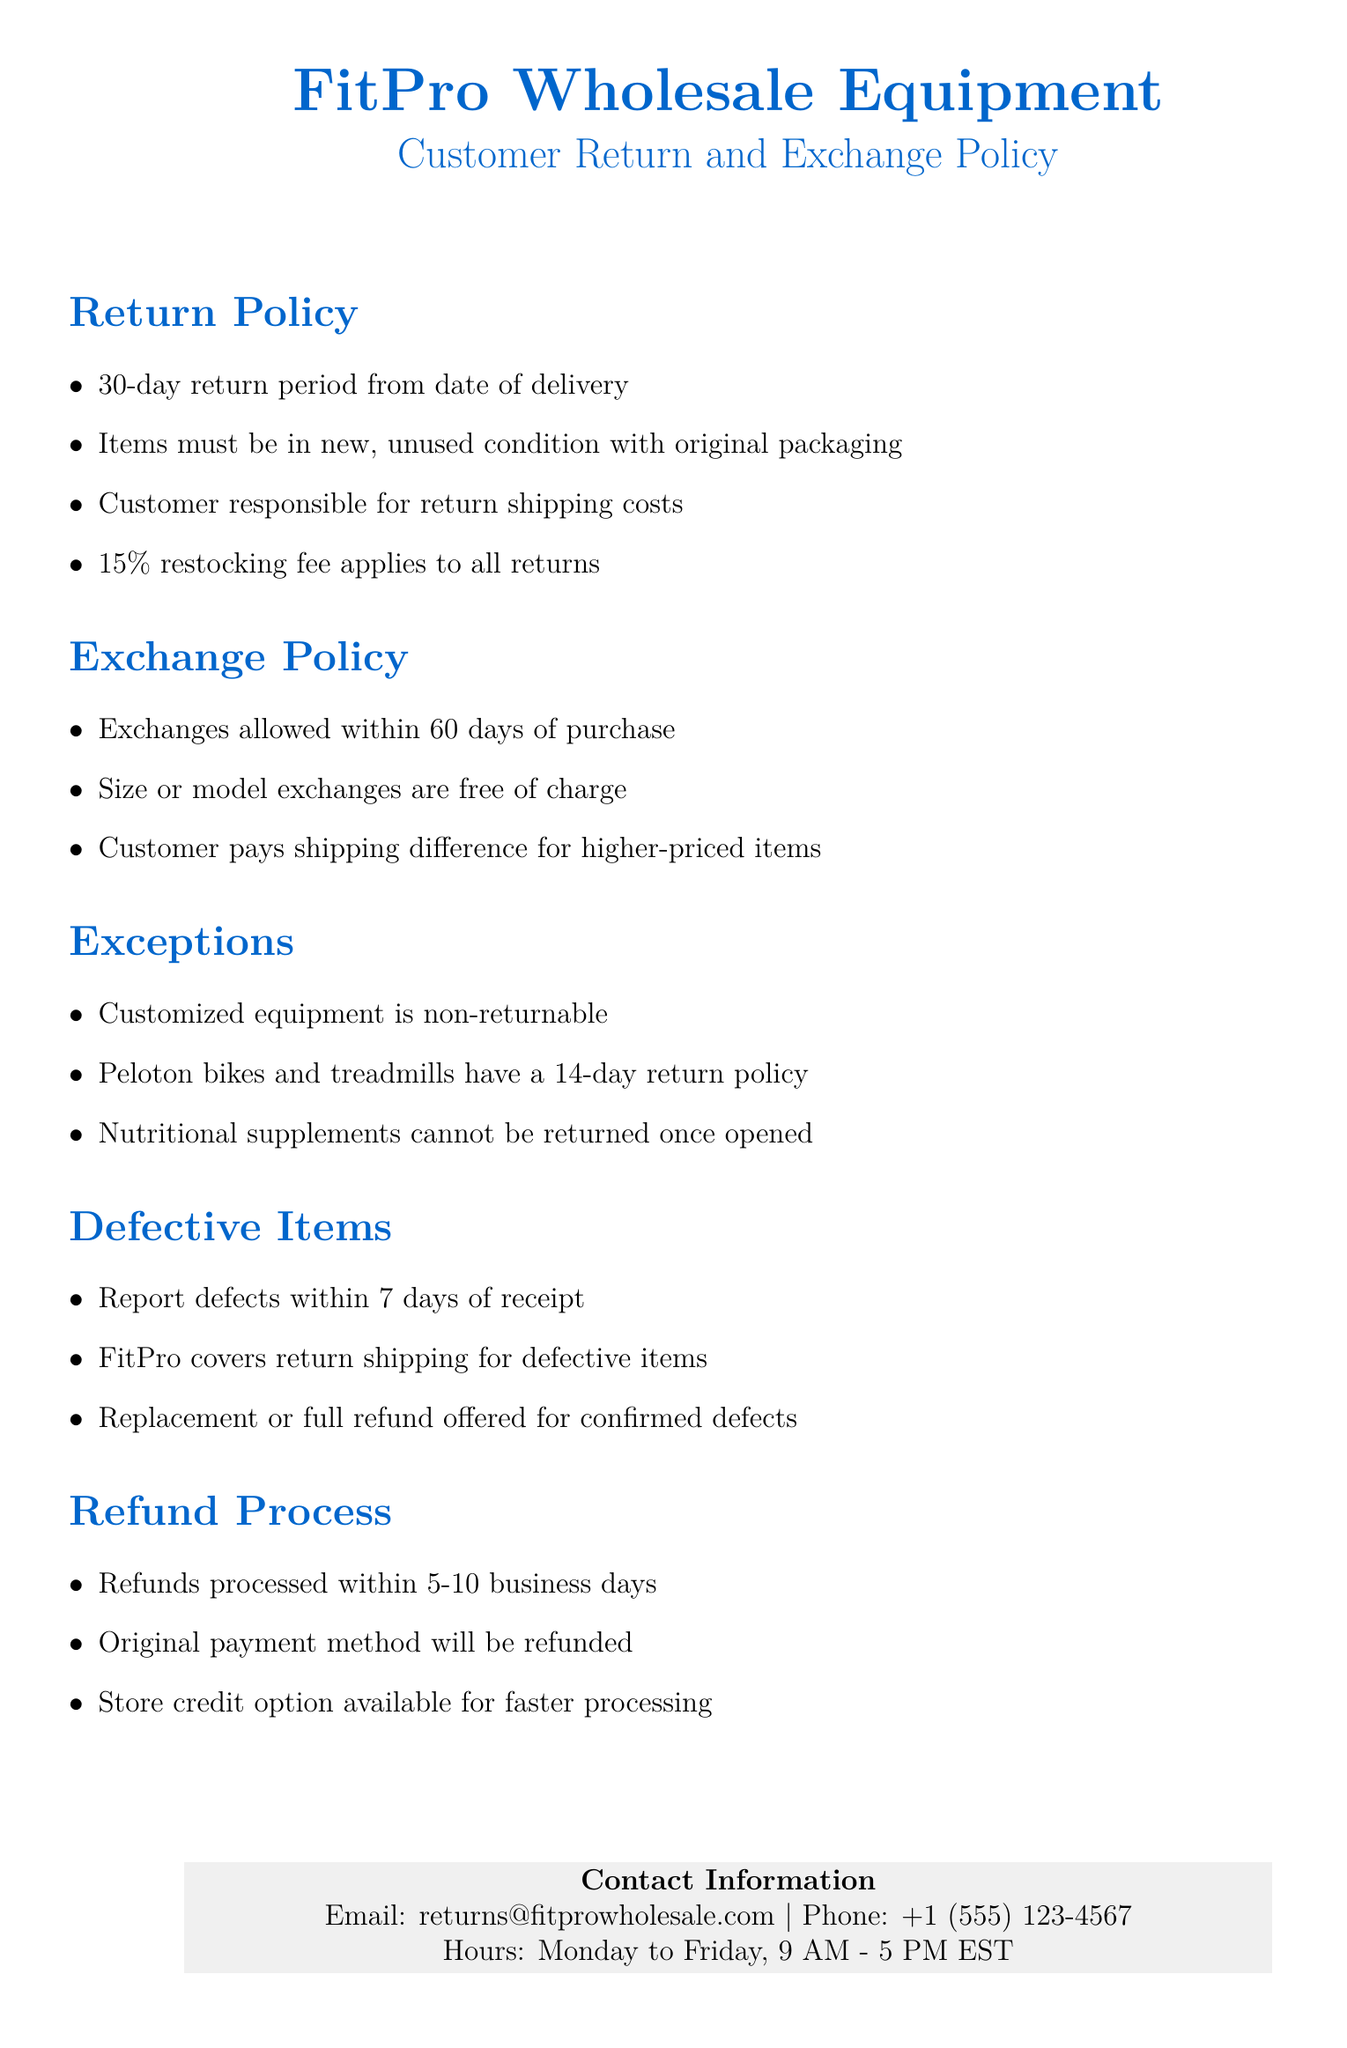What is the return period for items? The return policy states that items must be returned within 30 days from the date of delivery.
Answer: 30 days What is the restocking fee for returns? The policy specifies that a 15% restocking fee applies to all returns.
Answer: 15% What items are non-returnable? The document lists customized equipment as non-returnable.
Answer: Customized equipment How long does a customer have to report defective items? Customers are required to report defects within 7 days of receipt of the item.
Answer: 7 days What happens if items are exchanged for a higher price? The customer is responsible for paying the shipping difference for higher-priced items during an exchange.
Answer: Shipping difference What is the process for refunds? Refunds are processed within 5-10 business days using the original payment method.
Answer: 5-10 business days What items have a different return policy of 14 days? Peloton bikes and treadmills have a separate return policy of 14 days.
Answer: Peloton bikes and treadmills Is there an option for faster processing of refunds? The customer can choose store credit as an option for faster processing of refunds.
Answer: Store credit How can customers contact FitPro for returns? Customers can contact FitPro through the email address provided in the document.
Answer: returns@fitprowholesale.com 